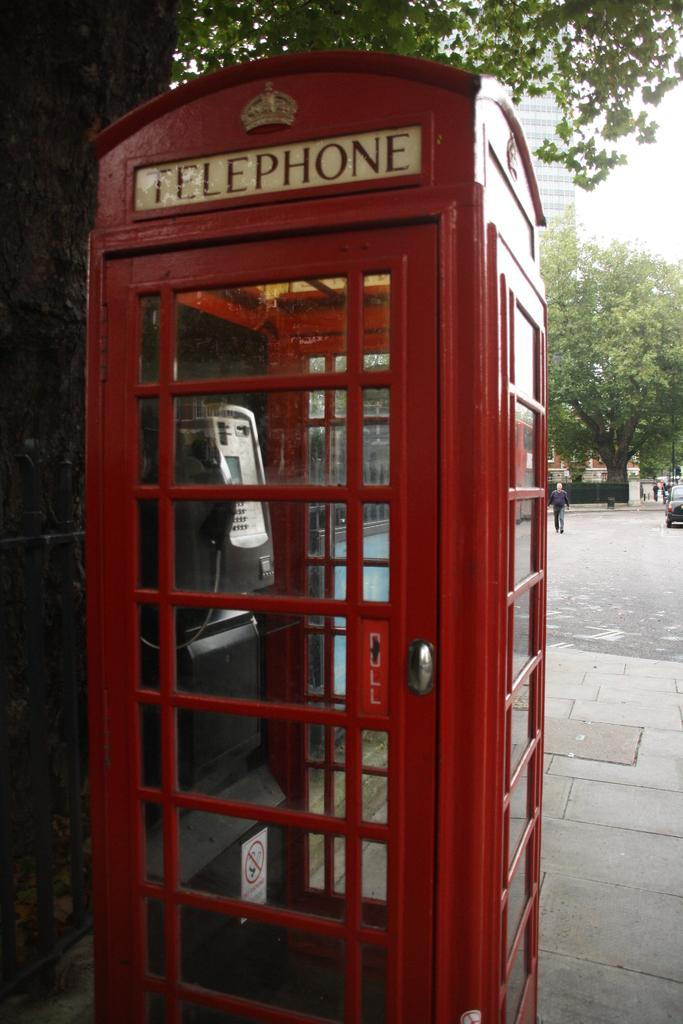Provide a one-sentence caption for the provided image. The door of a telephone booth reminds its prospective users to pull it open. 